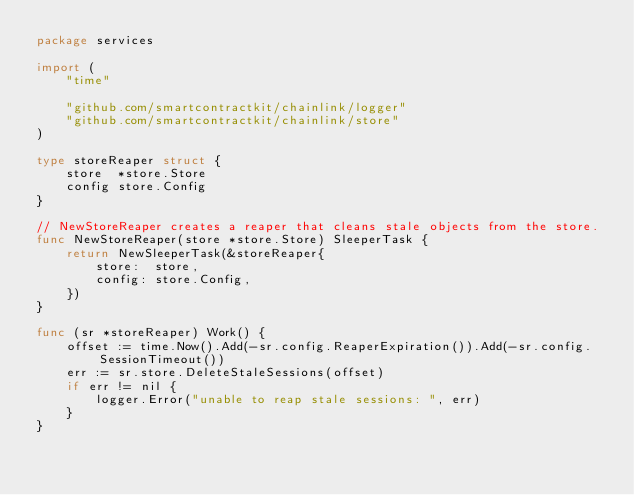<code> <loc_0><loc_0><loc_500><loc_500><_Go_>package services

import (
	"time"

	"github.com/smartcontractkit/chainlink/logger"
	"github.com/smartcontractkit/chainlink/store"
)

type storeReaper struct {
	store  *store.Store
	config store.Config
}

// NewStoreReaper creates a reaper that cleans stale objects from the store.
func NewStoreReaper(store *store.Store) SleeperTask {
	return NewSleeperTask(&storeReaper{
		store:  store,
		config: store.Config,
	})
}

func (sr *storeReaper) Work() {
	offset := time.Now().Add(-sr.config.ReaperExpiration()).Add(-sr.config.SessionTimeout())
	err := sr.store.DeleteStaleSessions(offset)
	if err != nil {
		logger.Error("unable to reap stale sessions: ", err)
	}
}
</code> 